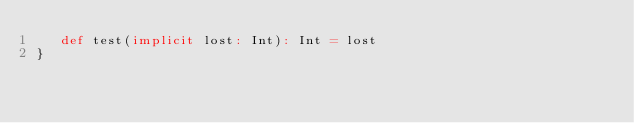Convert code to text. <code><loc_0><loc_0><loc_500><loc_500><_Scala_>   def test(implicit lost: Int): Int = lost
}
</code> 